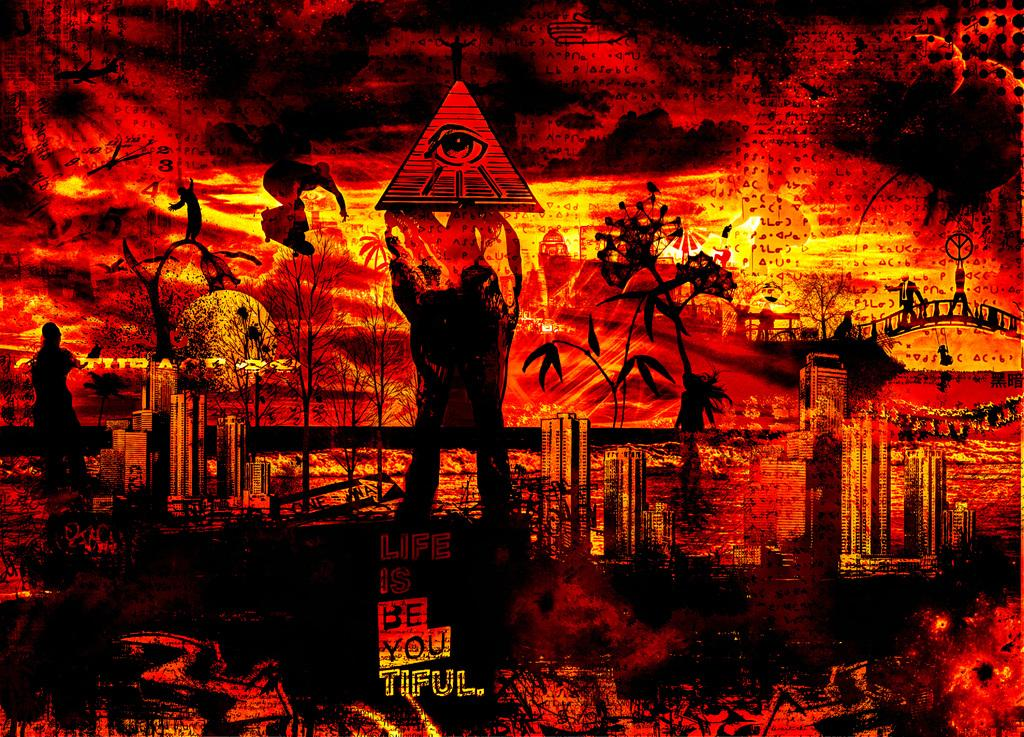<image>
Write a terse but informative summary of the picture. dark cataclysmic picture of someone holding a triangle with an eye in eye and words at bottom of picture be you tiful 